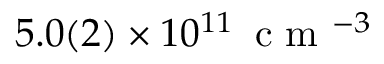Convert formula to latex. <formula><loc_0><loc_0><loc_500><loc_500>5 . 0 ( 2 ) \times 1 0 ^ { 1 1 } \, c m ^ { - 3 }</formula> 